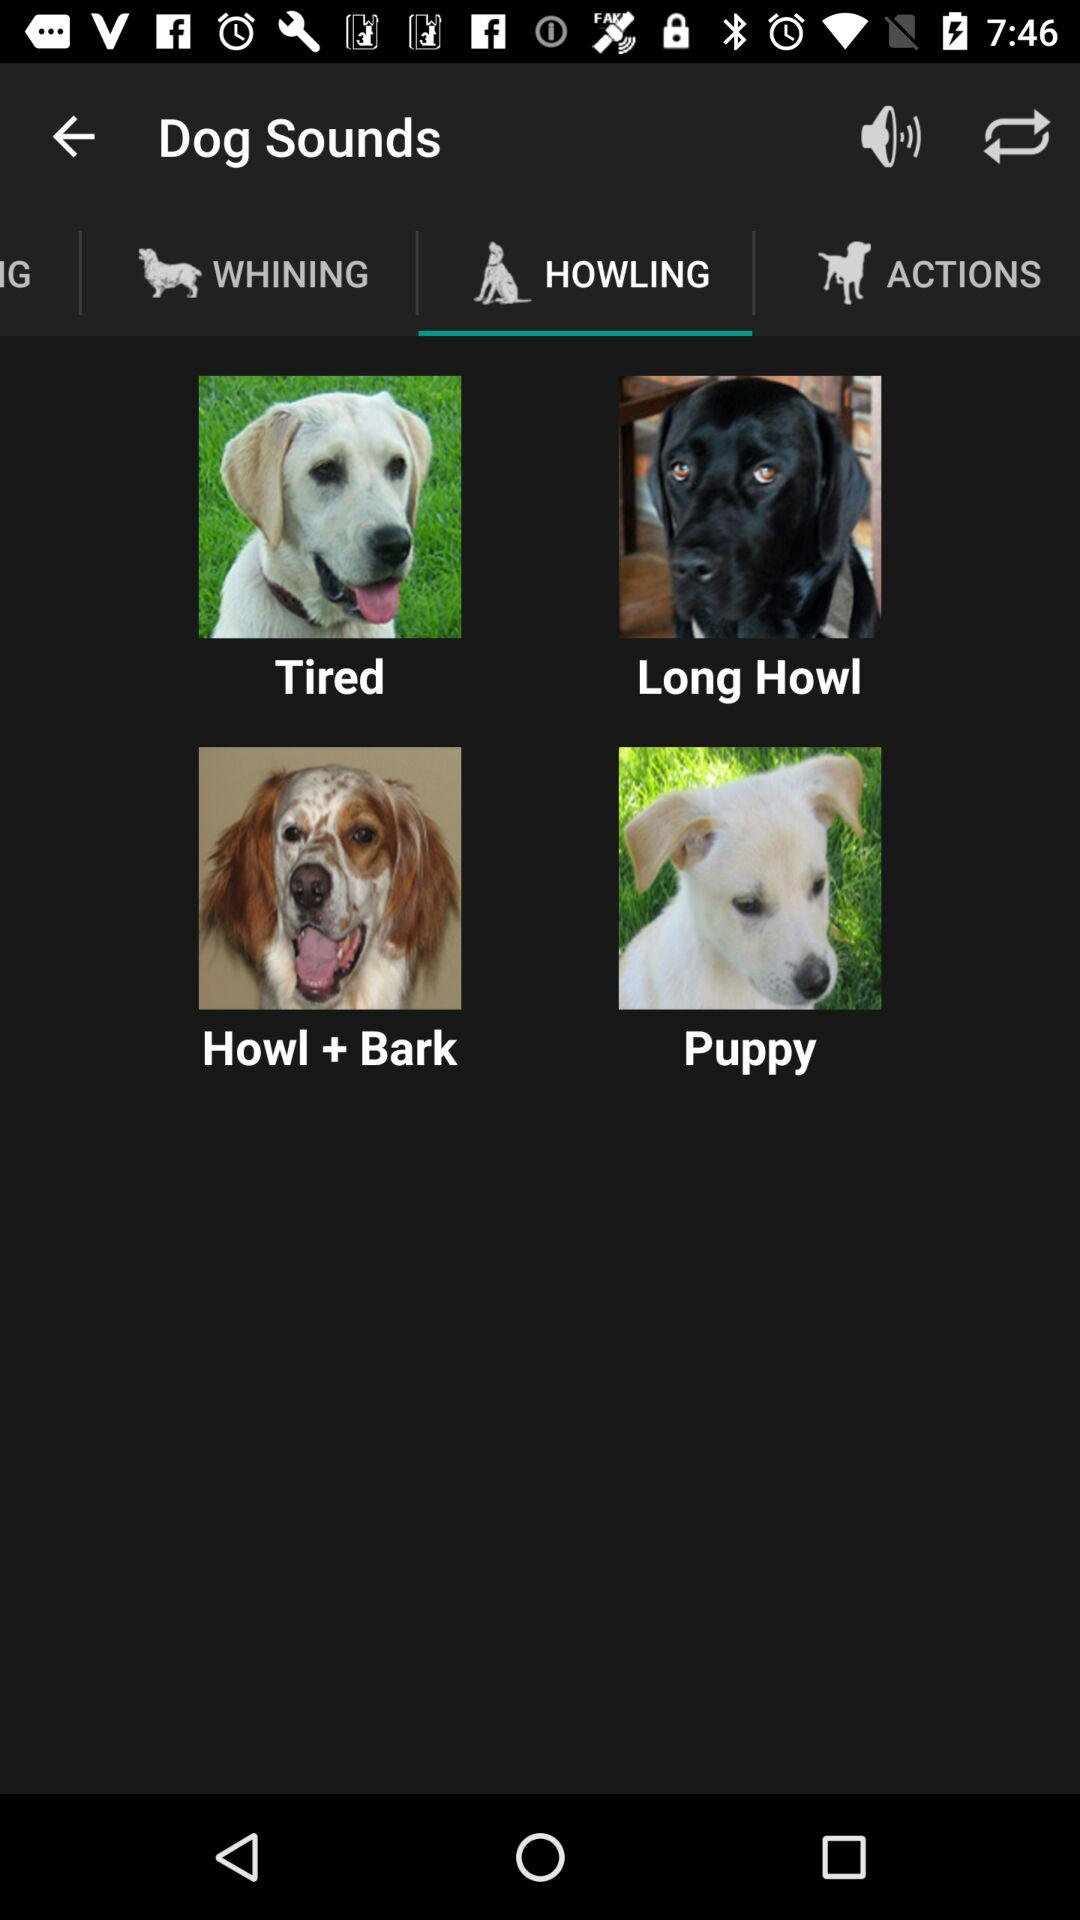Which tab has been selected? The tab that has been selected is "HOWLING". 